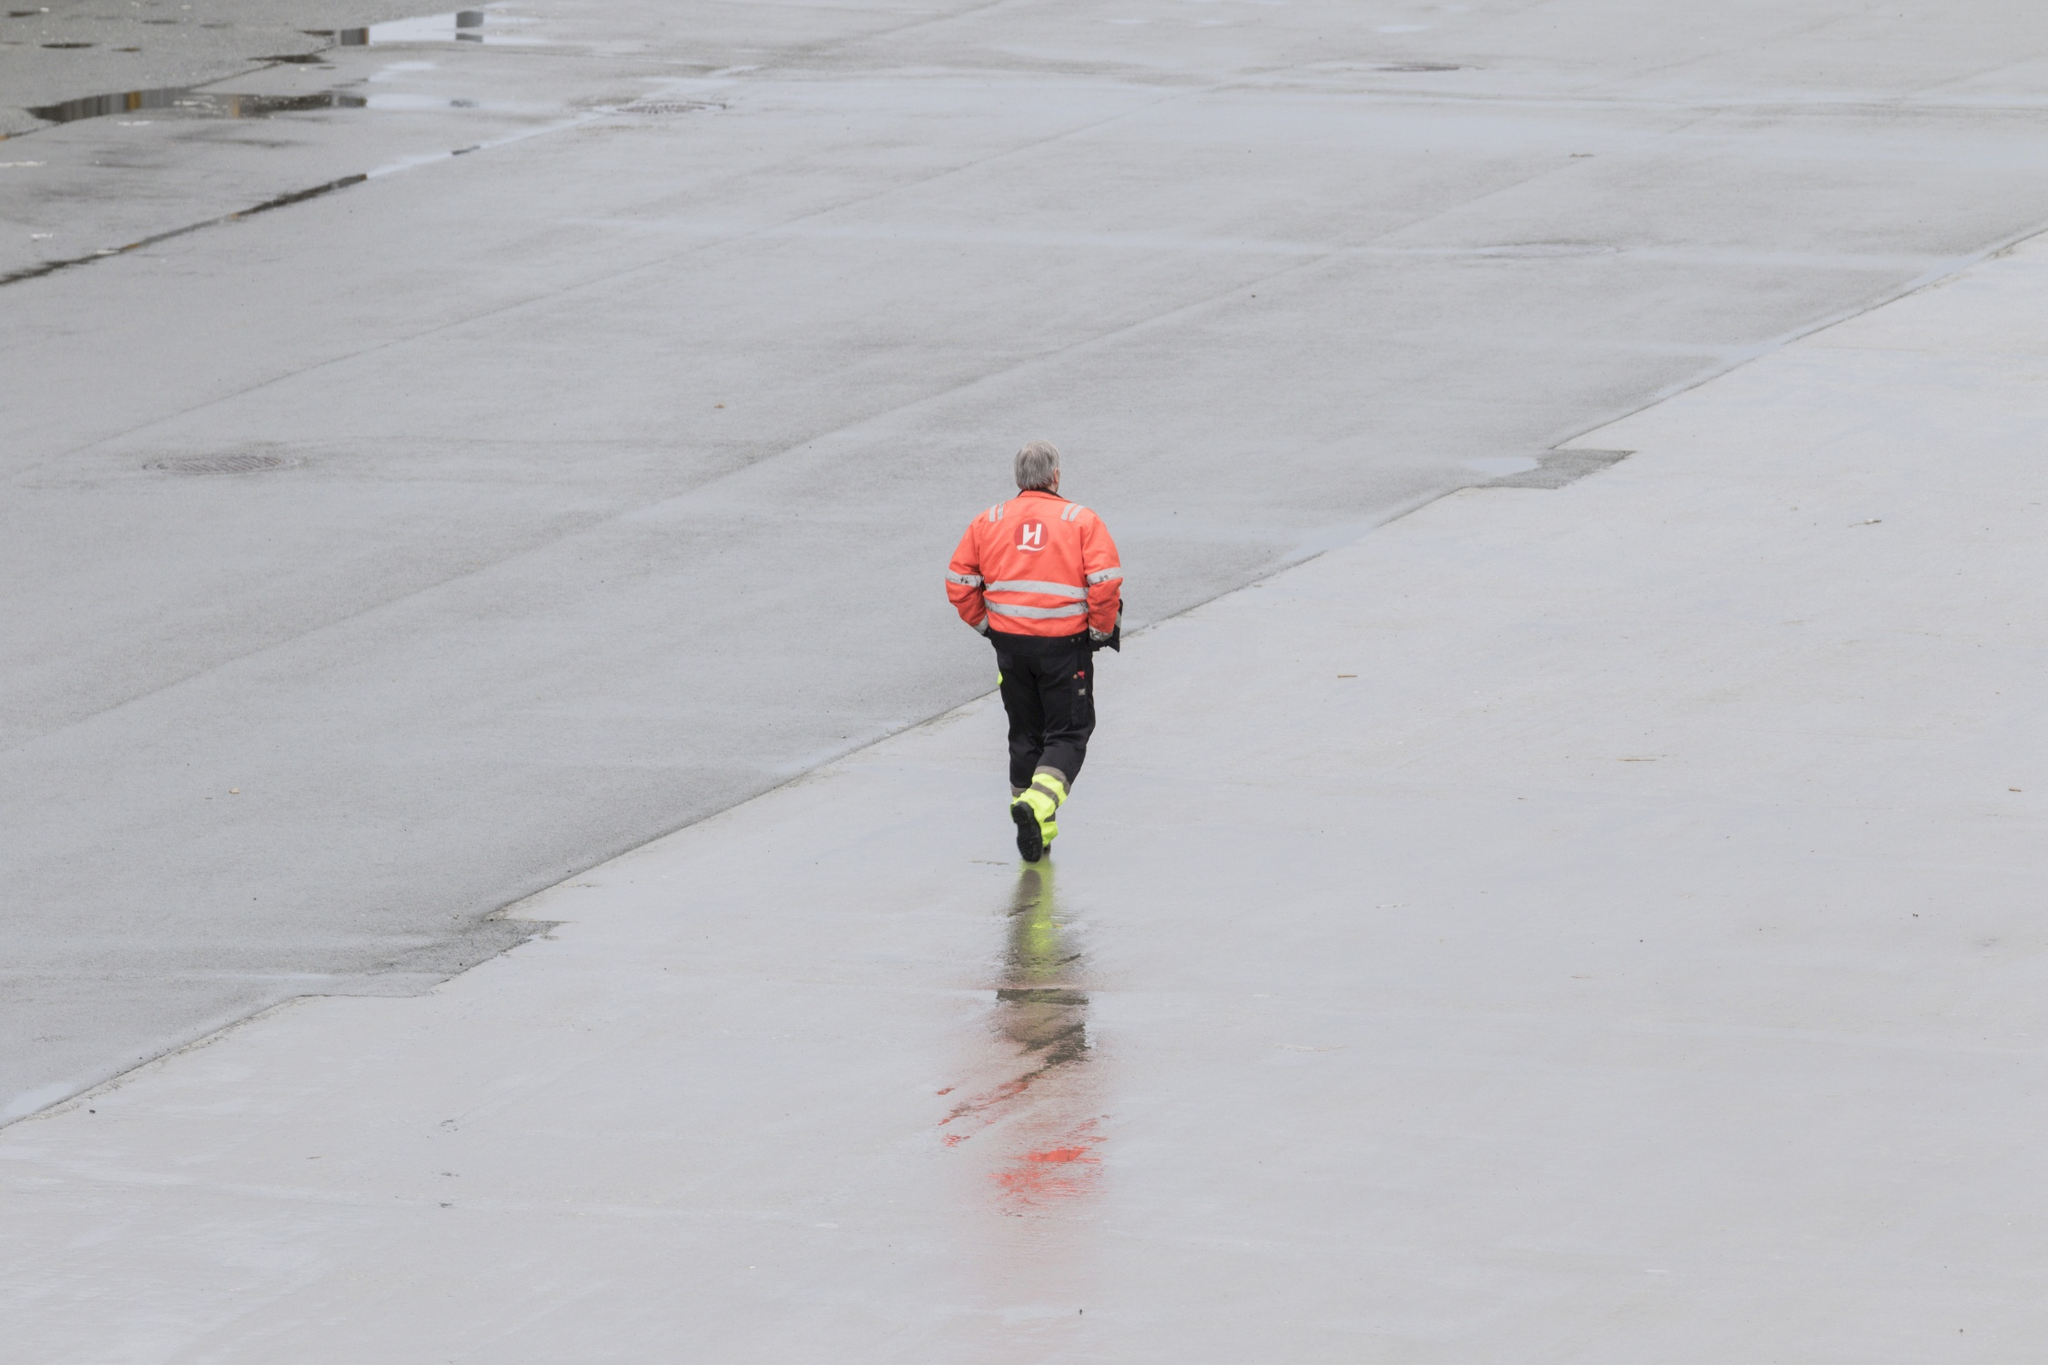What does the environment tell us about where this person might be? The image depicts a vast concrete area with no immediate buildings or structures in close proximity. The overcast sky and the presence of puddles suggest a recent rainfall. Such environments are often part of industrial facilities, airports, or large commercial sites where maintenance and inspections are regularly conducted due to the scale of operations and safety concerns.  There's a sense of isolation in the image. Can you comment on that? Indeed, the person appears isolated in their task. This could reflect the nature of the work — it may require individual attention or it happens in a controlled area where access is restricted. Additionally, the image captures a moment where no one else is present in the frame, which amplifies the sense of solitude. The isolation might also suggest that this task needs to be performed with minimal distractions or without the interference of others. 